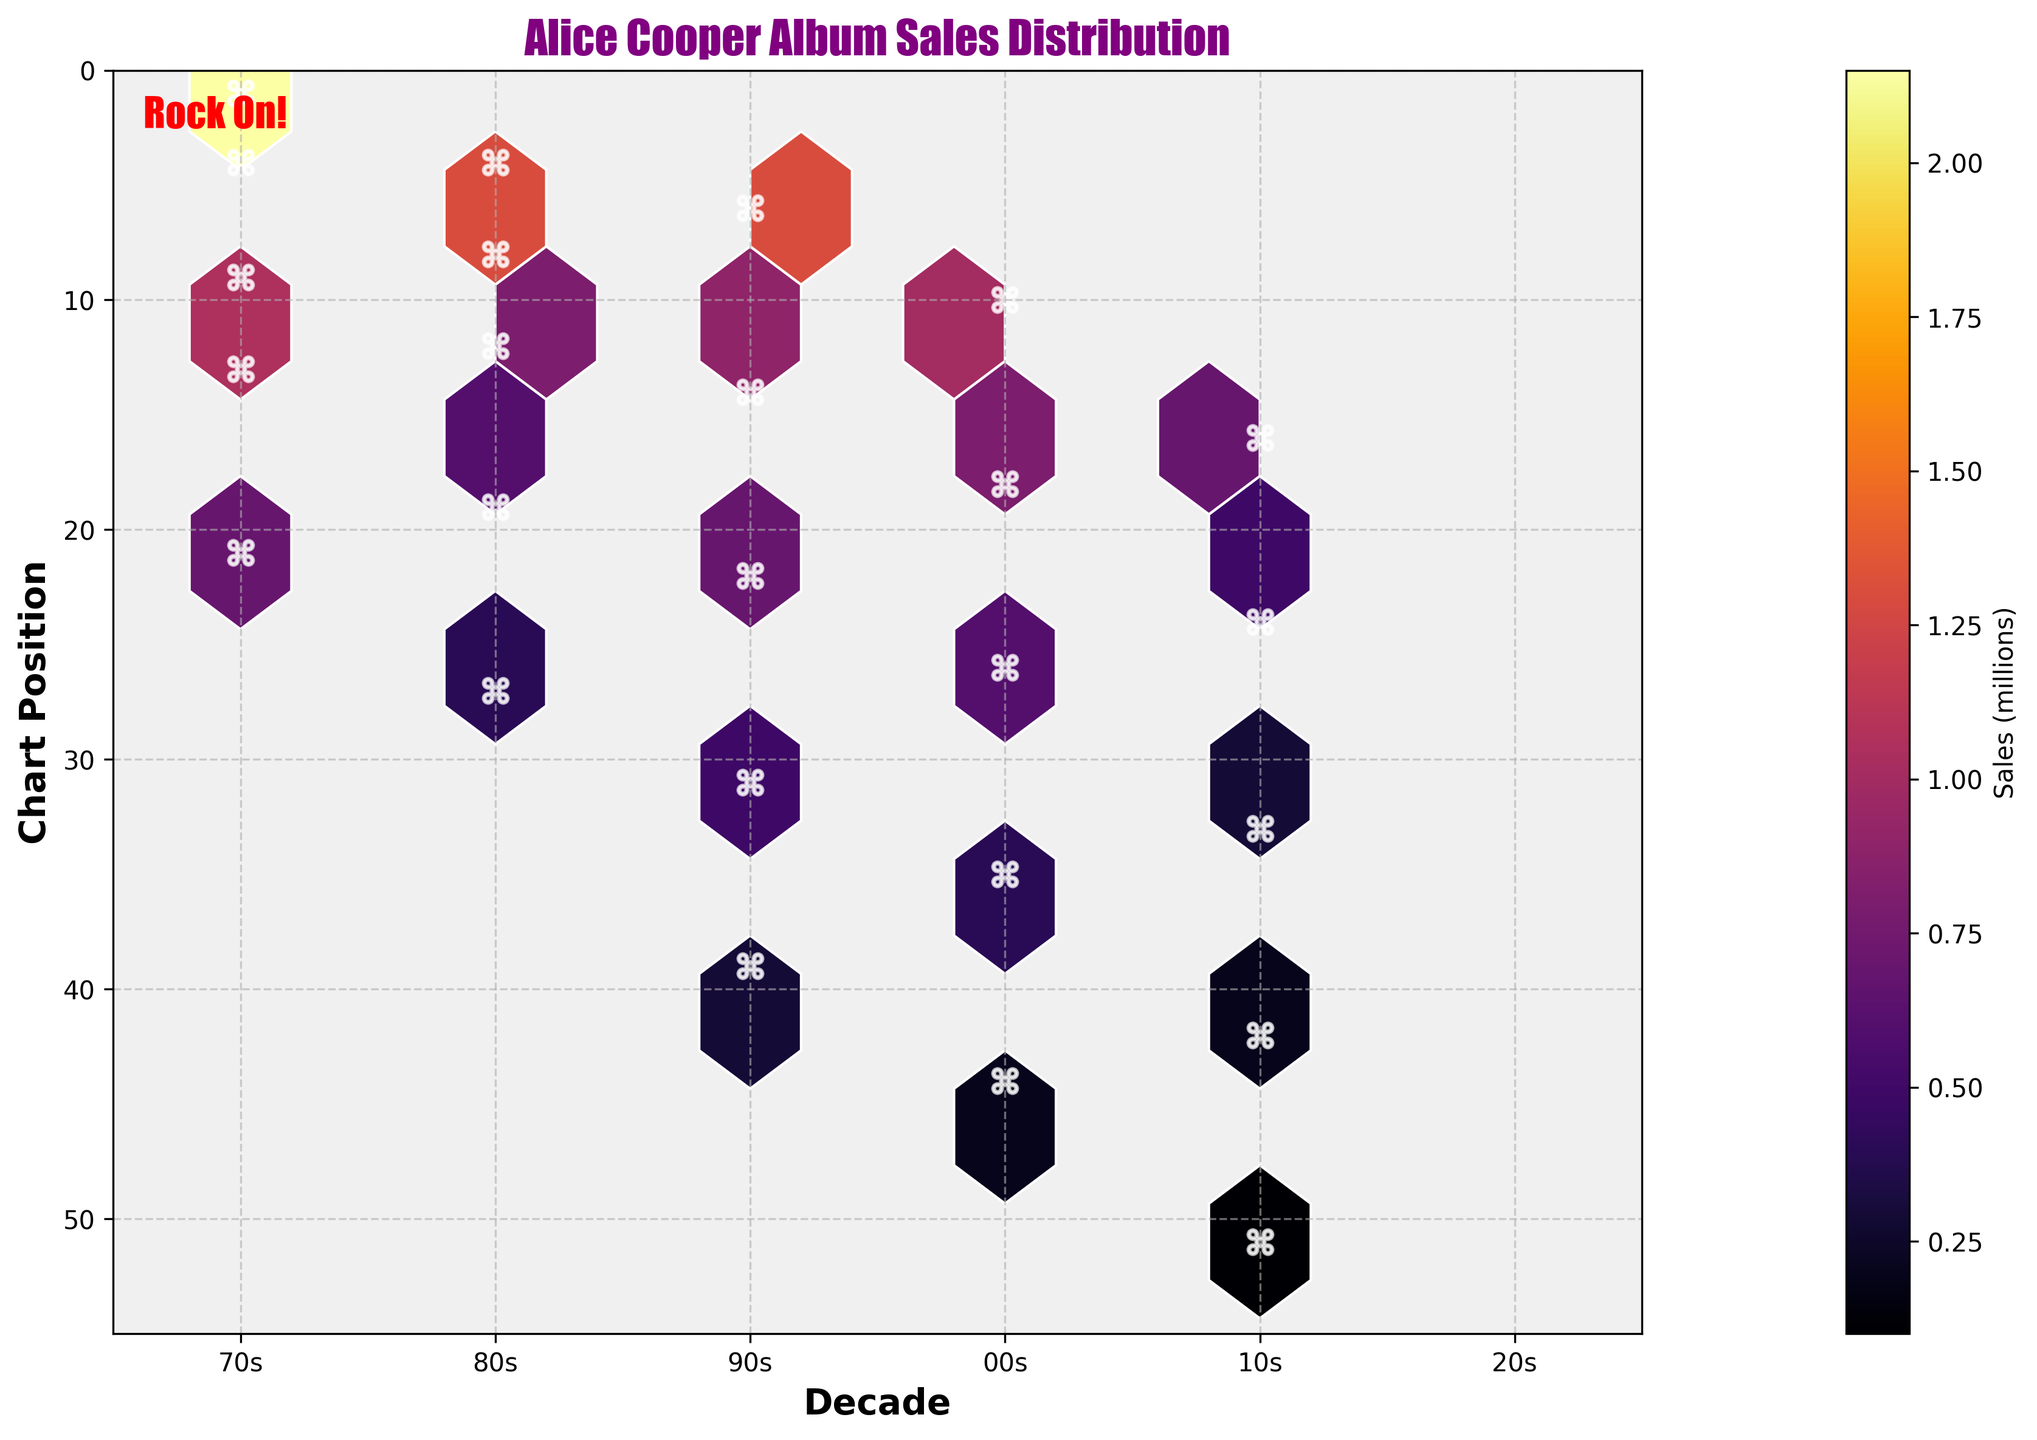What is the title of the plot? The title of the plot is located at the top of the figure. It gives an overview of what the plot is about. In this case, it is "Alice Cooper Album Sales Distribution."
Answer: Alice Cooper Album Sales Distribution How is the y-axis labeled, and what does it represent? The y-axis is labeled "Chart Position," which indicates the ranking position of Alice Cooper's albums on music charts. The higher positions are shown at the top of the axis.
Answer: Chart Position What's the color scheme used in the hexbin plot, and what does it represent? The color scheme is "inferno," a gradient that represents different levels of album sales in millions. Darker shades represent higher sales, and lighter shades indicate lower sales.
Answer: inferno Which decade shows the highest album sales concentration near the top chart positions? Observing the plot, the 1970s show the highest concentration near the top chart positions (positions 1 to 4) with darker shades, indicating higher album sales.
Answer: 1970s What pattern emerges about the distribution of album sales in the 1980s compared to the 2000s? To compare decades, the 1980s have notable album sales in positions 4 to 8, whereas the 2000s show fewer high sales with more scatter towards lower chart positions (26 to 44). This indicates declining commercial success over time.
Answer: The 1980s had higher sales and better chart positions compared to the 2000s What's the range of chart positions in the 1990s with decent sales (greater than 0.5 million)? In the plot, the 1990s decade shows hexagons with sales greater than 0.5 million primarily between chart positions 6 to 22. This range signifies decent commercial success.
Answer: 6 to 22 What's the overall trend in album sales and chart positions from the 1970s to the 2010s? The plot reveals a trend where earlier decades (1970s, 1980s) have higher sales and better chart positions, while later decades (2000s, 2010s) show a decline in both sales and chart positions, indicating a downward trend in commercial success.
Answer: Downward trend in sales and chart positions What can you infer about the low sales (around 0.1 million) distribution across all decades? Observing the lightest shades, low sales (around 0.1 million) are present in all decades, especially in positions lower than 30, with increased frequency in recent decades (2010s).
Answer: Low sales are frequent across decades but more prominent recently How many top chart positions (1 to 10) are represented in the hexbin plot, and in which decades do they appear? Counting the positions in the axes of the hexbin plot, chart positions 1 to 10 appear in the 1970s, 1980s, 1990s, and 2000s. Each of these decades has at least one album in the top 10 chart positions.
Answer: Four decades (1970s, 1980s, 1990s, 2000s) Between the 2000s and 2010s, which decade has the highest average album sales based on the plot? Summing the weighted sales indicated by color within hexagons: the 2000s show higher average sales with shades indicating more albums closer to 1 million or higher, contrasted to predominantly lighter shades below 0.5 million in the 2010s.
Answer: 2000s 